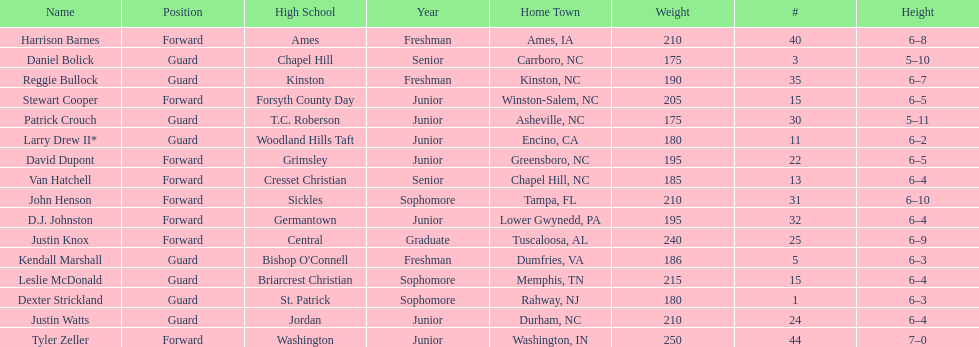How many players are not a junior? 9. 